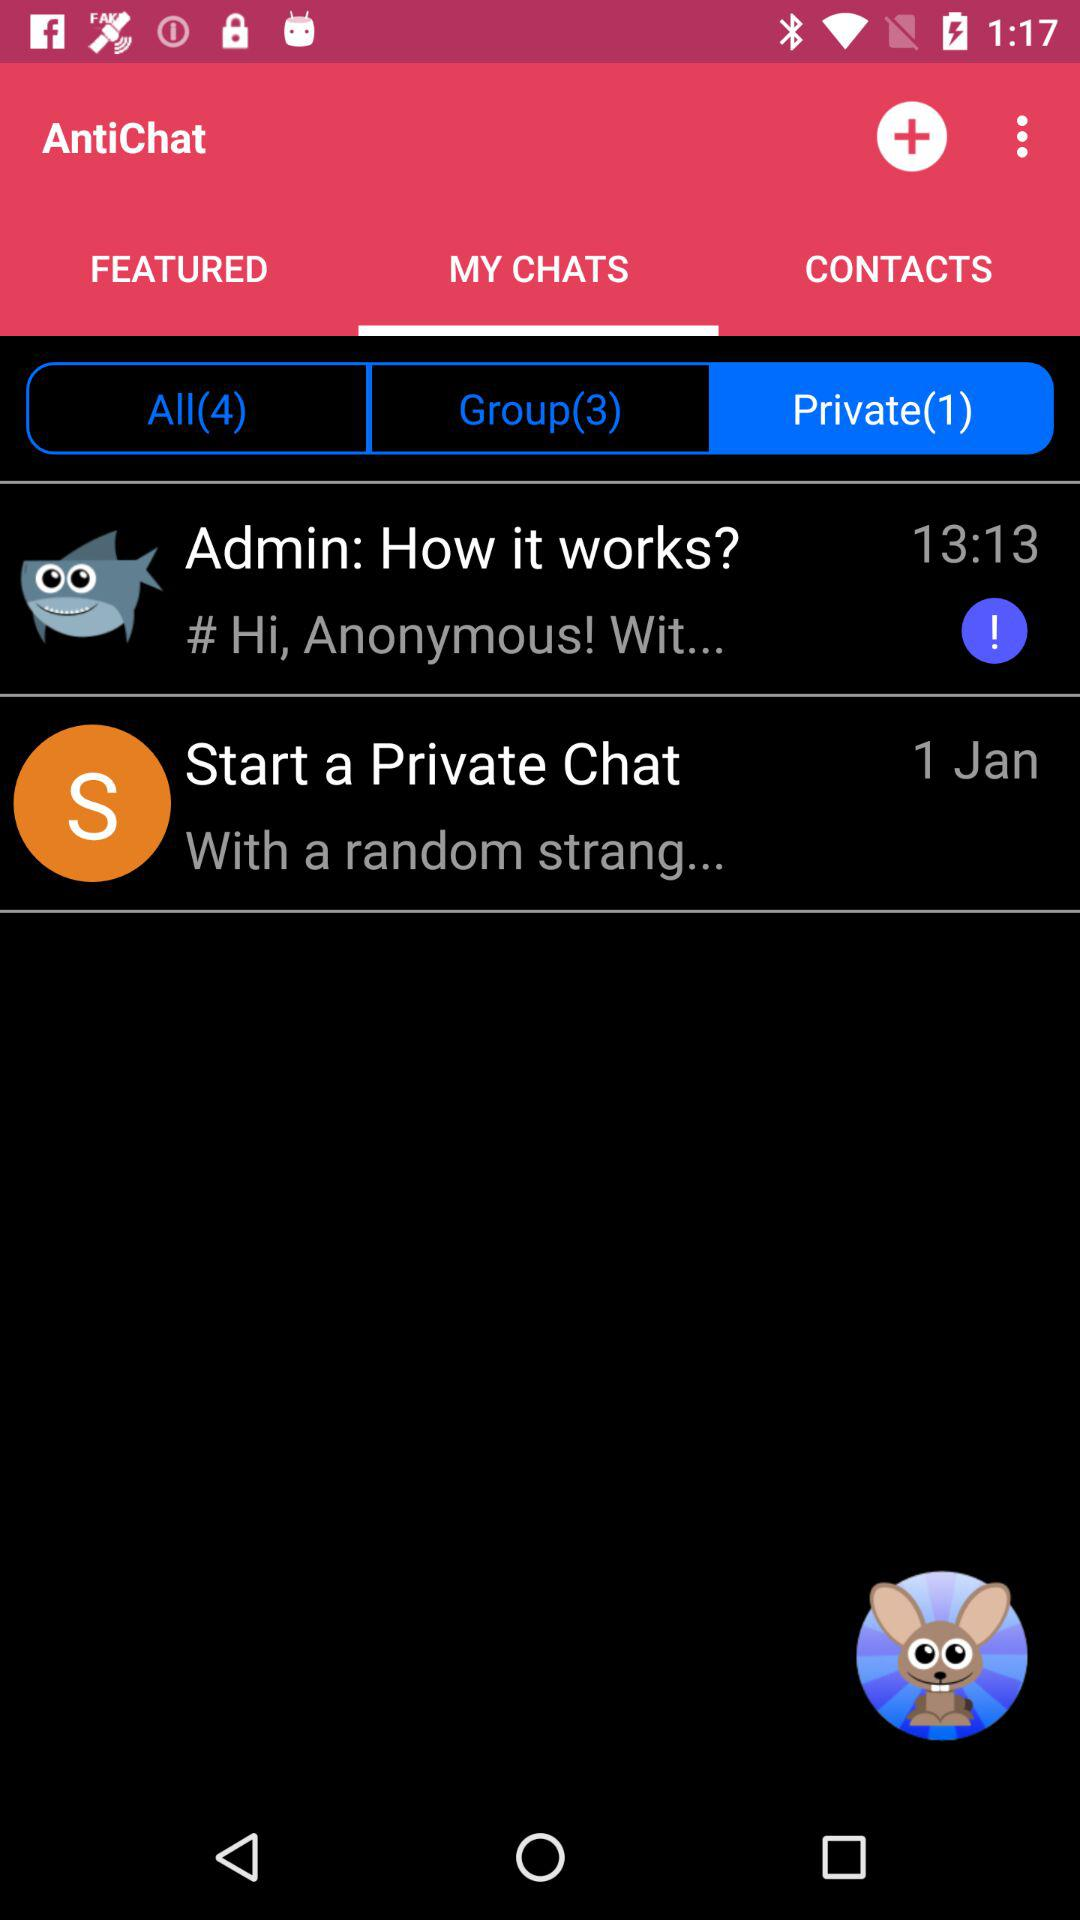How many private chats are there? There is 1 private chat. 